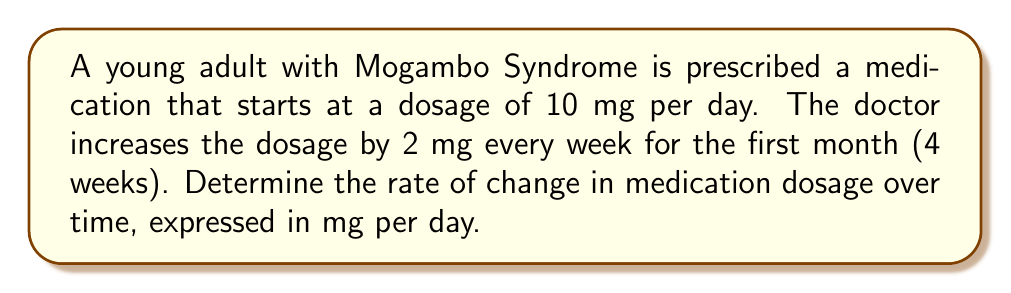Can you solve this math problem? To determine the rate of change in medication dosage over time, we need to consider the following:

1. Initial dosage: 10 mg per day
2. Increase in dosage: 2 mg per week
3. Time period: 4 weeks

We can calculate the rate of change using the formula:

$$ \text{Rate of change} = \frac{\text{Change in dosage}}{\text{Change in time}} $$

First, let's calculate the total change in dosage over the 4-week period:
$$ \text{Total change in dosage} = 2 \text{ mg/week} \times 4 \text{ weeks} = 8 \text{ mg} $$

Now, we need to express the time in days:
$$ 4 \text{ weeks} = 4 \times 7 = 28 \text{ days} $$

Applying the rate of change formula:

$$ \text{Rate of change} = \frac{8 \text{ mg}}{28 \text{ days}} = \frac{2}{7} \text{ mg/day} $$

To simplify this fraction, we can divide both the numerator and denominator by 2:

$$ \text{Rate of change} = \frac{1}{3.5} \text{ mg/day} $$
Answer: The rate of change in medication dosage over time is $\frac{2}{7}$ mg per day, or approximately 0.2857 mg per day. 